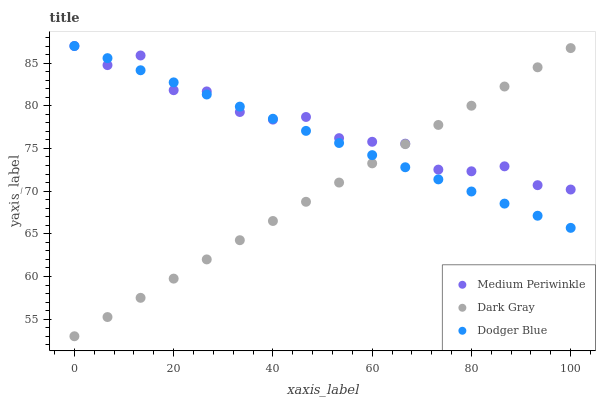Does Dark Gray have the minimum area under the curve?
Answer yes or no. Yes. Does Medium Periwinkle have the maximum area under the curve?
Answer yes or no. Yes. Does Dodger Blue have the minimum area under the curve?
Answer yes or no. No. Does Dodger Blue have the maximum area under the curve?
Answer yes or no. No. Is Dodger Blue the smoothest?
Answer yes or no. Yes. Is Medium Periwinkle the roughest?
Answer yes or no. Yes. Is Medium Periwinkle the smoothest?
Answer yes or no. No. Is Dodger Blue the roughest?
Answer yes or no. No. Does Dark Gray have the lowest value?
Answer yes or no. Yes. Does Dodger Blue have the lowest value?
Answer yes or no. No. Does Medium Periwinkle have the highest value?
Answer yes or no. Yes. Does Medium Periwinkle intersect Dark Gray?
Answer yes or no. Yes. Is Medium Periwinkle less than Dark Gray?
Answer yes or no. No. Is Medium Periwinkle greater than Dark Gray?
Answer yes or no. No. 